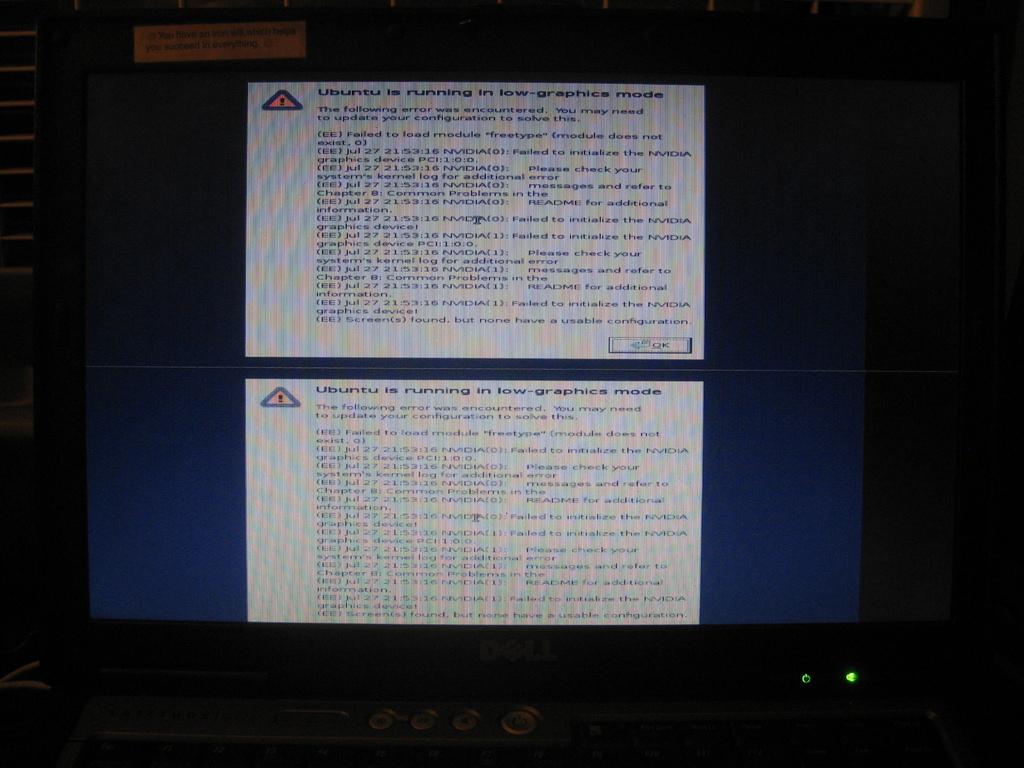What does the text say?
Offer a terse response. Ubuntu is running in low graphics mode. Does this say ubuntu is running?
Your answer should be very brief. Yes. 